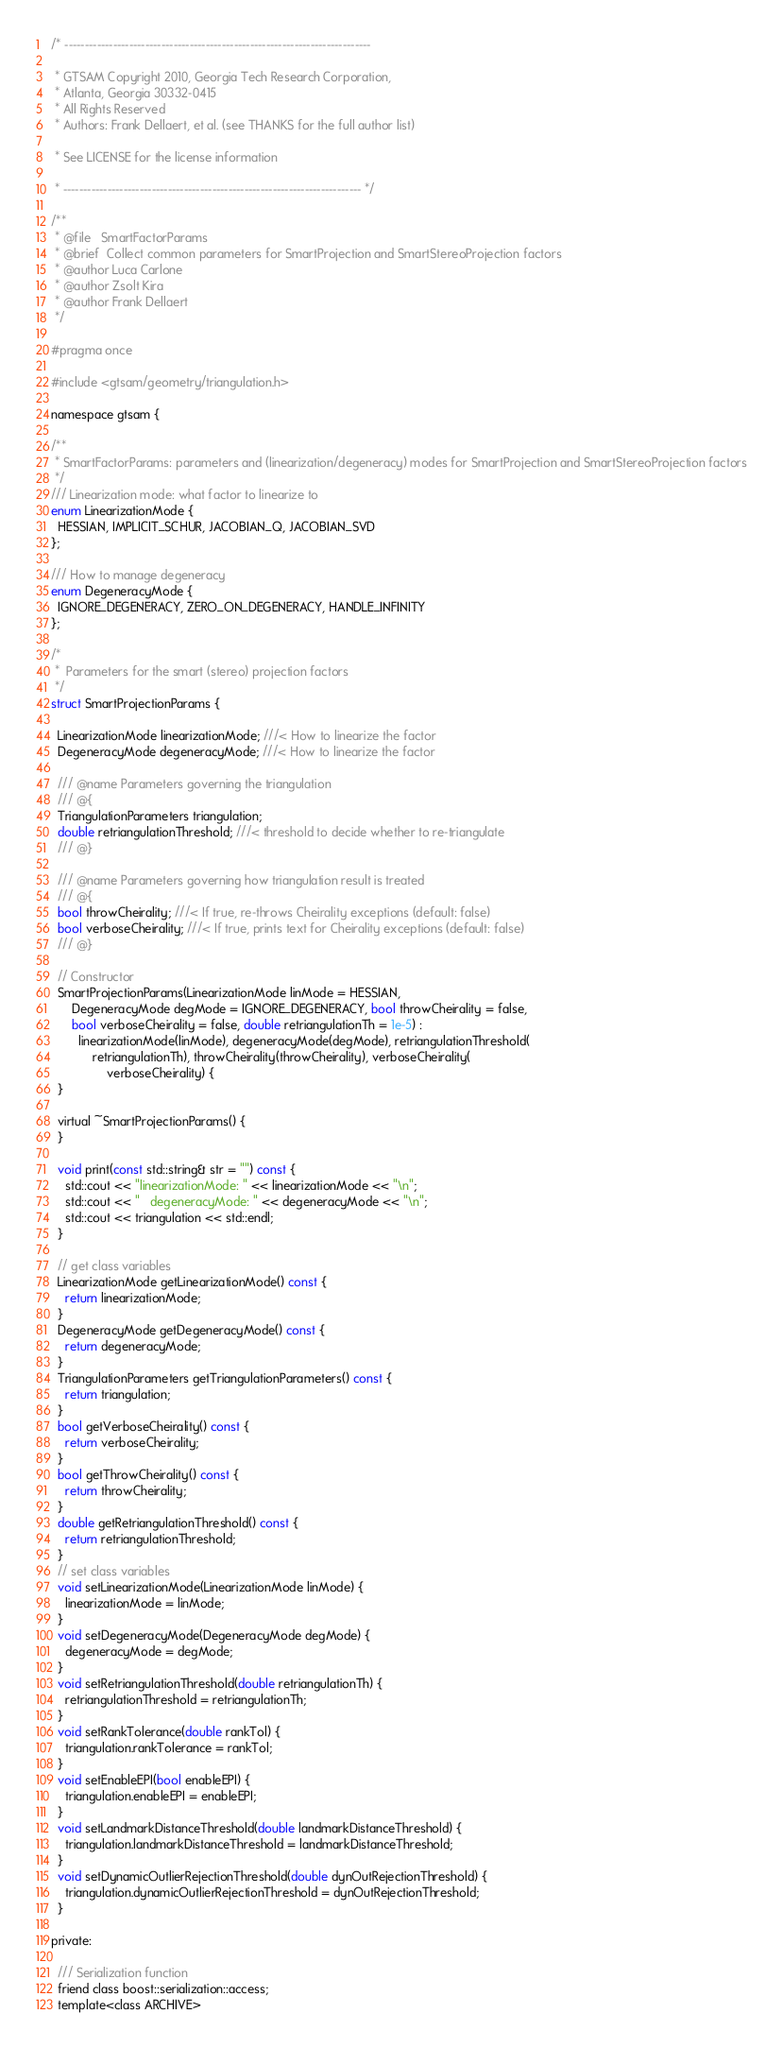<code> <loc_0><loc_0><loc_500><loc_500><_C_>/* ----------------------------------------------------------------------------

 * GTSAM Copyright 2010, Georgia Tech Research Corporation,
 * Atlanta, Georgia 30332-0415
 * All Rights Reserved
 * Authors: Frank Dellaert, et al. (see THANKS for the full author list)

 * See LICENSE for the license information

 * -------------------------------------------------------------------------- */

/**
 * @file   SmartFactorParams
 * @brief  Collect common parameters for SmartProjection and SmartStereoProjection factors
 * @author Luca Carlone
 * @author Zsolt Kira
 * @author Frank Dellaert
 */

#pragma once

#include <gtsam/geometry/triangulation.h>

namespace gtsam {

/**
 * SmartFactorParams: parameters and (linearization/degeneracy) modes for SmartProjection and SmartStereoProjection factors
 */
/// Linearization mode: what factor to linearize to
enum LinearizationMode {
  HESSIAN, IMPLICIT_SCHUR, JACOBIAN_Q, JACOBIAN_SVD
};

/// How to manage degeneracy
enum DegeneracyMode {
  IGNORE_DEGENERACY, ZERO_ON_DEGENERACY, HANDLE_INFINITY
};

/*
 *  Parameters for the smart (stereo) projection factors
 */
struct SmartProjectionParams {

  LinearizationMode linearizationMode; ///< How to linearize the factor
  DegeneracyMode degeneracyMode; ///< How to linearize the factor

  /// @name Parameters governing the triangulation
  /// @{
  TriangulationParameters triangulation;
  double retriangulationThreshold; ///< threshold to decide whether to re-triangulate
  /// @}

  /// @name Parameters governing how triangulation result is treated
  /// @{
  bool throwCheirality; ///< If true, re-throws Cheirality exceptions (default: false)
  bool verboseCheirality; ///< If true, prints text for Cheirality exceptions (default: false)
  /// @}

  // Constructor
  SmartProjectionParams(LinearizationMode linMode = HESSIAN,
      DegeneracyMode degMode = IGNORE_DEGENERACY, bool throwCheirality = false,
      bool verboseCheirality = false, double retriangulationTh = 1e-5) :
        linearizationMode(linMode), degeneracyMode(degMode), retriangulationThreshold(
            retriangulationTh), throwCheirality(throwCheirality), verboseCheirality(
                verboseCheirality) {
  }

  virtual ~SmartProjectionParams() {
  }

  void print(const std::string& str = "") const {
    std::cout << "linearizationMode: " << linearizationMode << "\n";
    std::cout << "   degeneracyMode: " << degeneracyMode << "\n";
    std::cout << triangulation << std::endl;
  }

  // get class variables
  LinearizationMode getLinearizationMode() const {
    return linearizationMode;
  }
  DegeneracyMode getDegeneracyMode() const {
    return degeneracyMode;
  }
  TriangulationParameters getTriangulationParameters() const {
    return triangulation;
  }
  bool getVerboseCheirality() const {
    return verboseCheirality;
  }
  bool getThrowCheirality() const {
    return throwCheirality;
  }
  double getRetriangulationThreshold() const {
    return retriangulationThreshold;
  }
  // set class variables
  void setLinearizationMode(LinearizationMode linMode) {
    linearizationMode = linMode;
  }
  void setDegeneracyMode(DegeneracyMode degMode) {
    degeneracyMode = degMode;
  }
  void setRetriangulationThreshold(double retriangulationTh) {
    retriangulationThreshold = retriangulationTh;
  }
  void setRankTolerance(double rankTol) {
    triangulation.rankTolerance = rankTol;
  }
  void setEnableEPI(bool enableEPI) {
    triangulation.enableEPI = enableEPI;
  }
  void setLandmarkDistanceThreshold(double landmarkDistanceThreshold) {
    triangulation.landmarkDistanceThreshold = landmarkDistanceThreshold;
  }
  void setDynamicOutlierRejectionThreshold(double dynOutRejectionThreshold) {
    triangulation.dynamicOutlierRejectionThreshold = dynOutRejectionThreshold;
  }

private:

  /// Serialization function
  friend class boost::serialization::access;
  template<class ARCHIVE></code> 